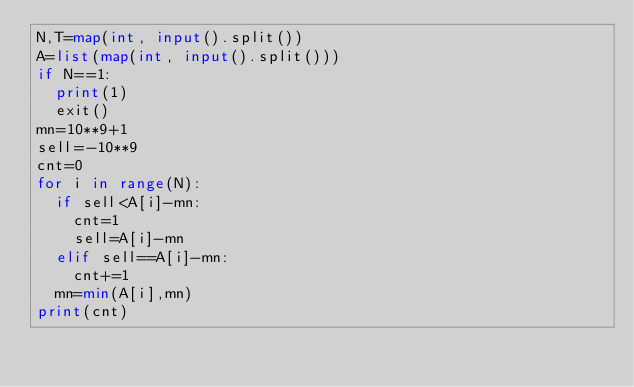<code> <loc_0><loc_0><loc_500><loc_500><_Python_>N,T=map(int, input().split())
A=list(map(int, input().split()))
if N==1:
  print(1)
  exit()
mn=10**9+1
sell=-10**9
cnt=0
for i in range(N):
  if sell<A[i]-mn:
    cnt=1
    sell=A[i]-mn
  elif sell==A[i]-mn:
    cnt+=1
  mn=min(A[i],mn)
print(cnt)</code> 